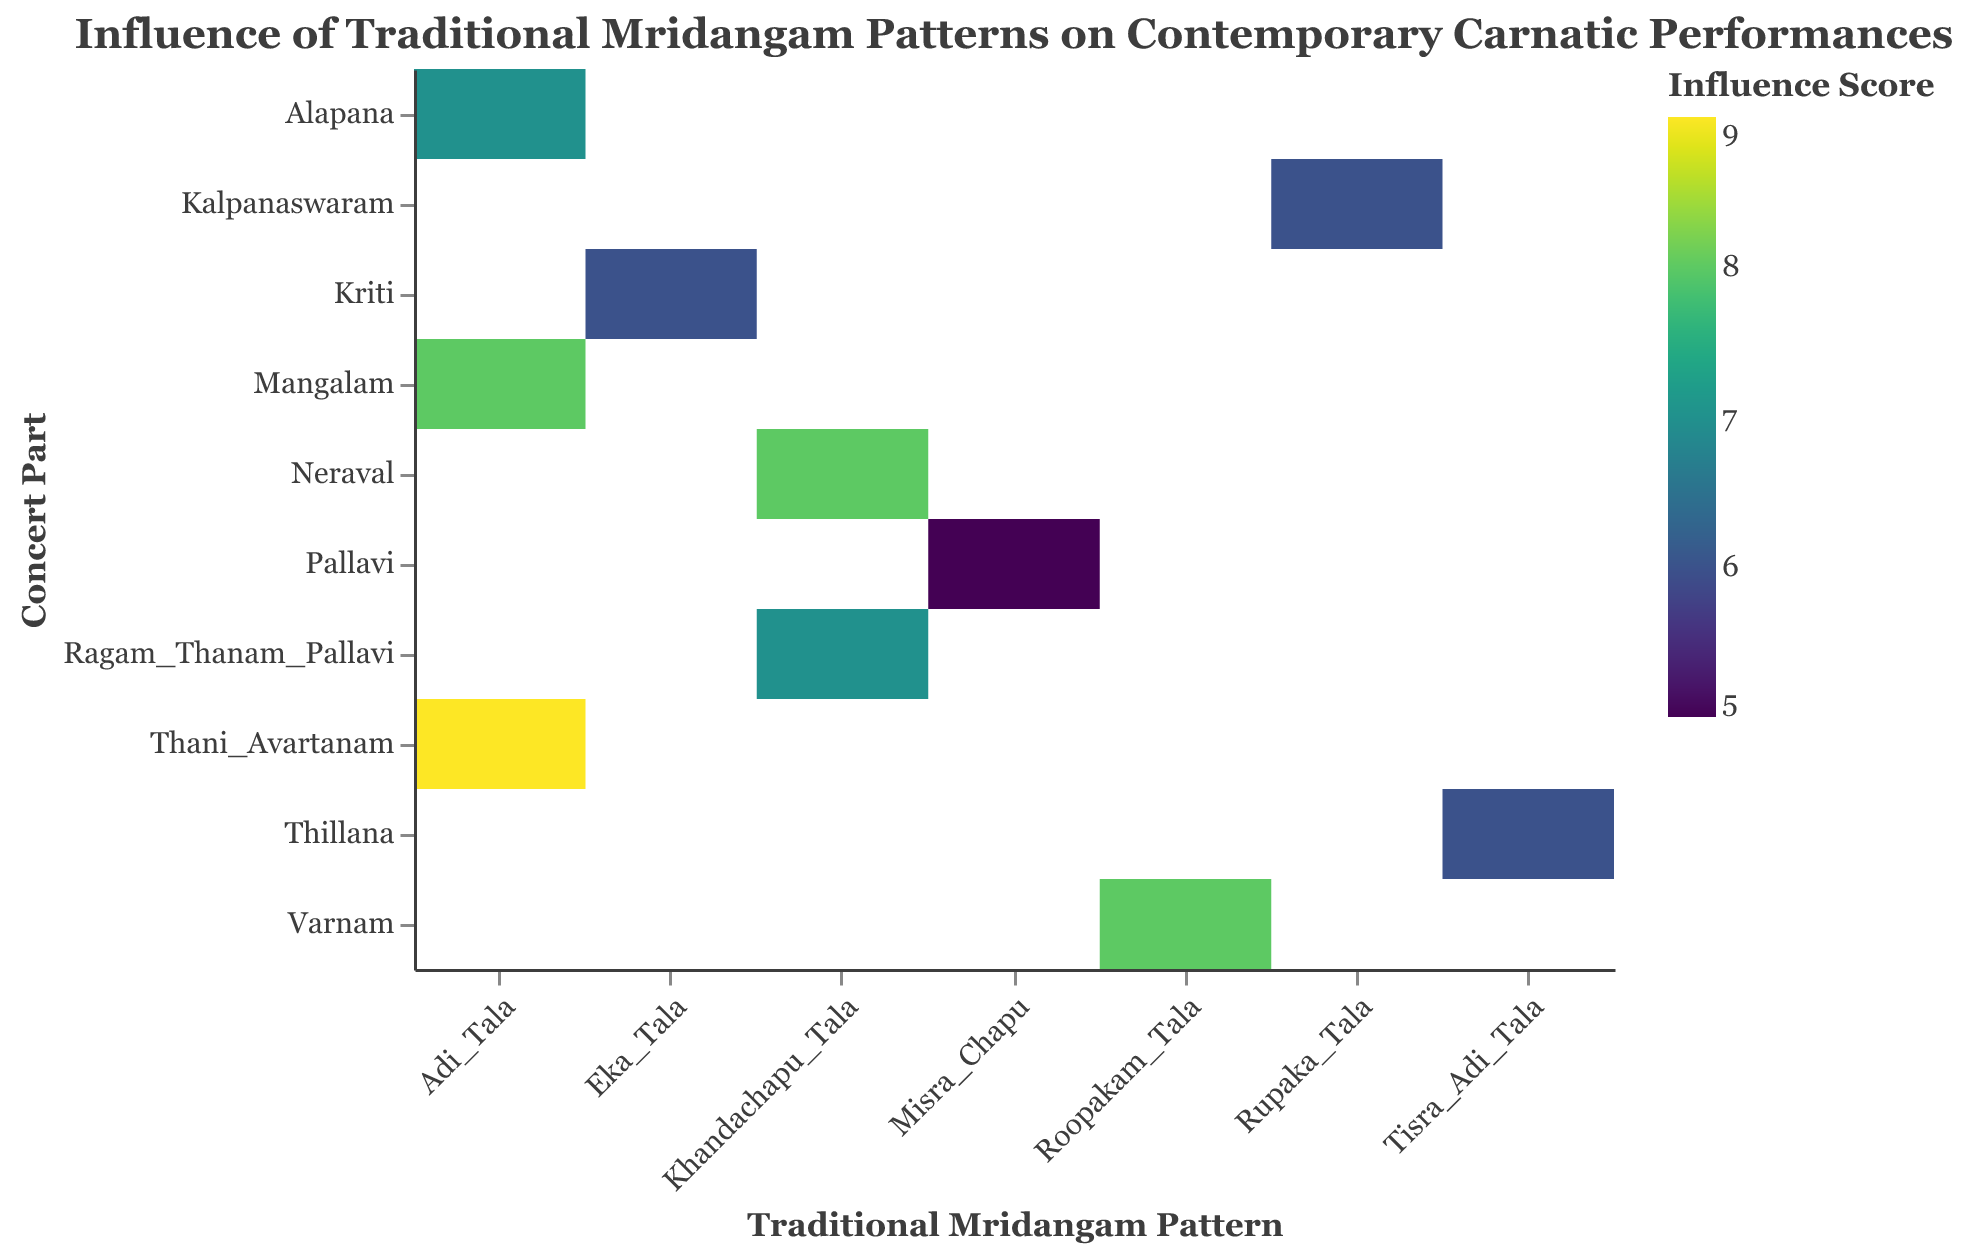What is the highest Influence Score in the heatmap? Look at the color gradient in the heatmap and find the darkest shade, then refer to the corresponding Influence Score in the tooltip. The highest Influence Score is 9.
Answer: 9 What is the Influence Score of the Thani Avartanam part using Adi Tala? Locate the cell where Concert Part is "Thani Avartanam" and Traditional Pattern is "Adi_Tala." The tooltip shows the Influence Score is 9.
Answer: 9 Which Traditional Mridangam Pattern is associated with the highest average Influence Score? Calculate the average Influence Score for each Traditional Pattern: Adi_Tala (7+9+8)/3 = 8, Khandachapu_Tala (8+7)/2 = 7.5, Rupaka_Tala = 6, Misra_Chapu = 5, Eka_Tala = 6, Roopakam_Tala = 8, Tisra_Adi_Tala = 6. The highest average is Adi_Tala with 8.
Answer: Adi_Tala How many Concert Parts are there in the heatmap? Count the unique values on the y-axis. The Concert Parts are Alapana, Neraval, Kalpanaswaram, Thani Avartanam, Pallavi, Kriti, Varnam, Mangalam, Ragam Thanam Pallavi, and Thillana, totaling 10.
Answer: 10 Which Concert Part has the lowest Influence Score? Find the lightest cell on the heatmap, then check the corresponding Concert Part. The lightest cell shows Pallavi with an Influence Score of 5.
Answer: Pallavi What is the Influence Score for Varnam using Roopakam Tala? Locate the cell where Concert Part is "Varnam" and Traditional Pattern is "Roopakam_Tala." The tooltip shows the Influence Score is 8.
Answer: 8 How does the Influence Score for Adi Tala vary across different Concert Parts? Analyze the cells with "Adi_Tala" pattern across different Concert Parts to see the corresponding Influence Scores. Alapana: 7, Thani Avartanam: 9, Mangalam: 8.
Answer: 7, 9, 8 Which Concert Title features the influence of Tisra Adi Tala? Find the cell with Traditional Pattern "Tisra_Adi_Tala" and check the Concert Title in the tooltip. The Concert Title is "Tamil_New_Year_Celebration."
Answer: Tamil_New_Year_Celebration Which Mridangam Artist played in the concert part of Kriti? Locate the cell with Concert Part "Kriti" and check the tooltip for the Mridangam Artist. The artist is Karaikudi Mani.
Answer: Karaikudi Mani Is the Influence Score of Mangalam using Adi Tala higher or lower than that of Alapana using Adi Tala? Compare the Influence Scores for Mangalam (Adi_Tala) and Alapana (Adi_Tala). Mangalam (Adi_Tala) has a score of 8, and Alapana (Adi_Tala) has a score of 7.
Answer: Higher 